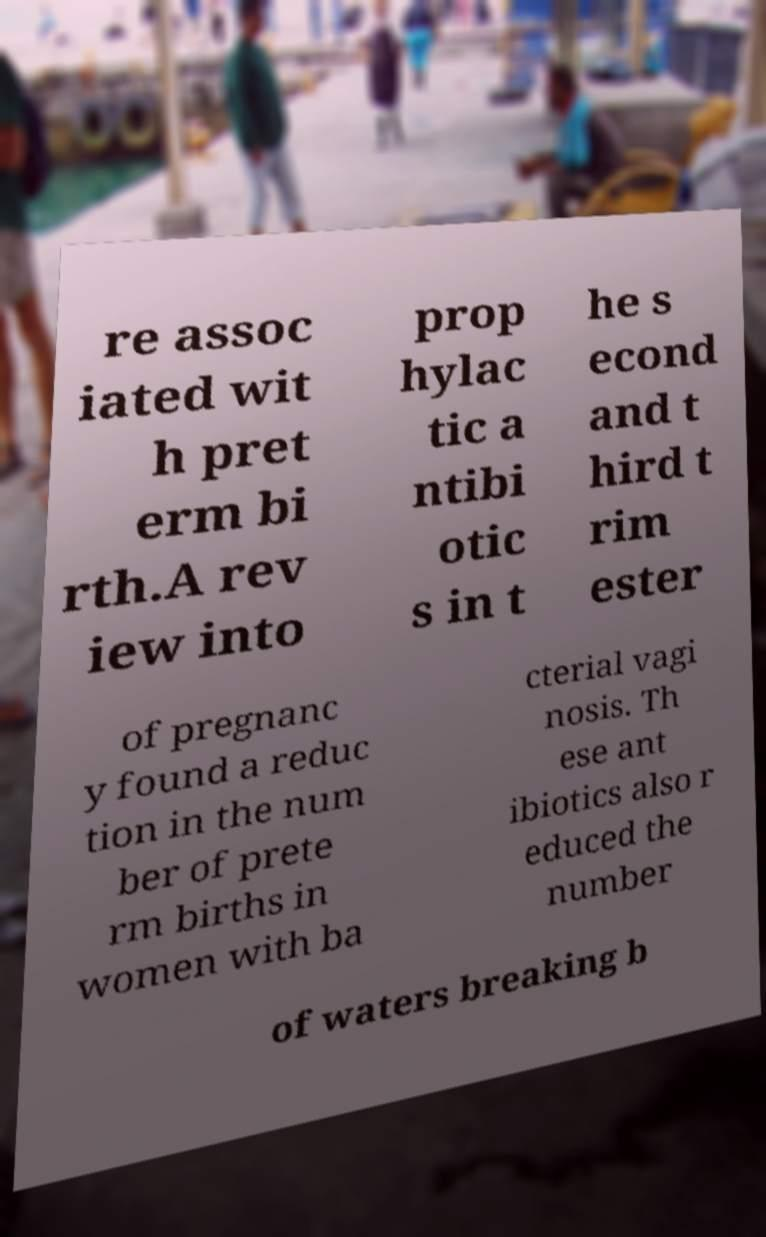I need the written content from this picture converted into text. Can you do that? re assoc iated wit h pret erm bi rth.A rev iew into prop hylac tic a ntibi otic s in t he s econd and t hird t rim ester of pregnanc y found a reduc tion in the num ber of prete rm births in women with ba cterial vagi nosis. Th ese ant ibiotics also r educed the number of waters breaking b 